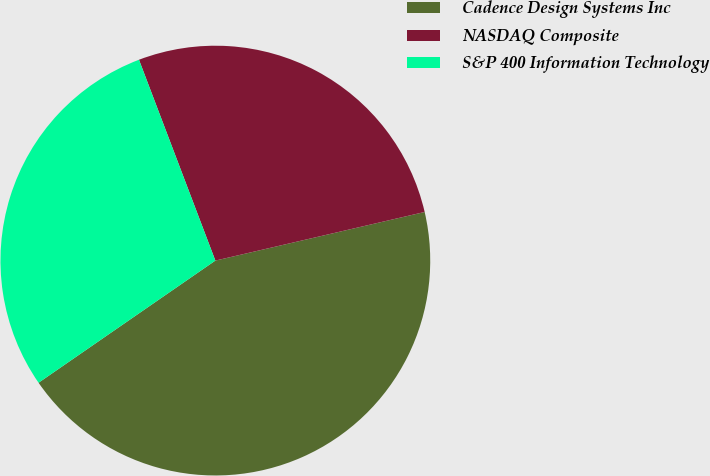Convert chart to OTSL. <chart><loc_0><loc_0><loc_500><loc_500><pie_chart><fcel>Cadence Design Systems Inc<fcel>NASDAQ Composite<fcel>S&P 400 Information Technology<nl><fcel>44.01%<fcel>27.15%<fcel>28.84%<nl></chart> 